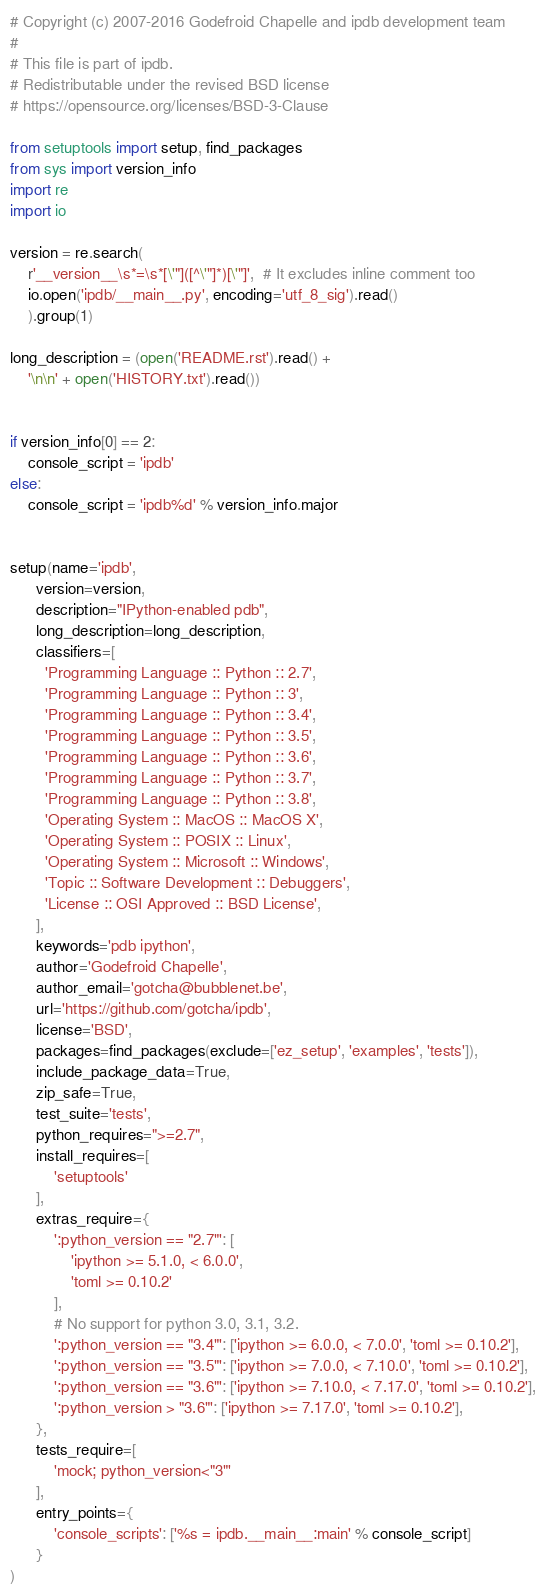<code> <loc_0><loc_0><loc_500><loc_500><_Python_># Copyright (c) 2007-2016 Godefroid Chapelle and ipdb development team
#
# This file is part of ipdb.
# Redistributable under the revised BSD license
# https://opensource.org/licenses/BSD-3-Clause

from setuptools import setup, find_packages
from sys import version_info
import re
import io

version = re.search(
    r'__version__\s*=\s*[\'"]([^\'"]*)[\'"]',  # It excludes inline comment too
    io.open('ipdb/__main__.py', encoding='utf_8_sig').read()
    ).group(1)

long_description = (open('README.rst').read() +
    '\n\n' + open('HISTORY.txt').read())


if version_info[0] == 2:
    console_script = 'ipdb'
else:
    console_script = 'ipdb%d' % version_info.major


setup(name='ipdb',
      version=version,
      description="IPython-enabled pdb",
      long_description=long_description,
      classifiers=[
        'Programming Language :: Python :: 2.7',
        'Programming Language :: Python :: 3',
        'Programming Language :: Python :: 3.4',
        'Programming Language :: Python :: 3.5',
        'Programming Language :: Python :: 3.6',
        'Programming Language :: Python :: 3.7',
        'Programming Language :: Python :: 3.8',
        'Operating System :: MacOS :: MacOS X',
        'Operating System :: POSIX :: Linux',
        'Operating System :: Microsoft :: Windows',
        'Topic :: Software Development :: Debuggers',
        'License :: OSI Approved :: BSD License',
      ],
      keywords='pdb ipython',
      author='Godefroid Chapelle',
      author_email='gotcha@bubblenet.be',
      url='https://github.com/gotcha/ipdb',
      license='BSD',
      packages=find_packages(exclude=['ez_setup', 'examples', 'tests']),
      include_package_data=True,
      zip_safe=True,
      test_suite='tests',
      python_requires=">=2.7",
      install_requires=[
          'setuptools'
      ],
      extras_require={
          ':python_version == "2.7"': [
              'ipython >= 5.1.0, < 6.0.0',
              'toml >= 0.10.2'
          ],
          # No support for python 3.0, 3.1, 3.2.
          ':python_version == "3.4"': ['ipython >= 6.0.0, < 7.0.0', 'toml >= 0.10.2'],
          ':python_version == "3.5"': ['ipython >= 7.0.0, < 7.10.0', 'toml >= 0.10.2'],
          ':python_version == "3.6"': ['ipython >= 7.10.0, < 7.17.0', 'toml >= 0.10.2'],
          ':python_version > "3.6"': ['ipython >= 7.17.0', 'toml >= 0.10.2'],
      },
      tests_require=[
          'mock; python_version<"3"'
      ],
      entry_points={
          'console_scripts': ['%s = ipdb.__main__:main' % console_script]
      }
)
</code> 